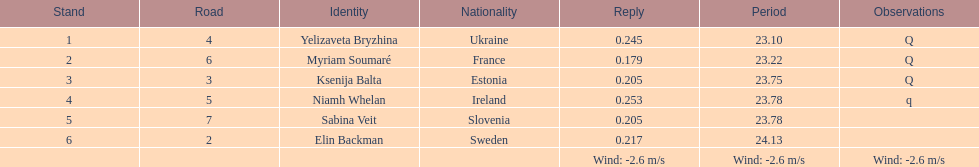Who is the first ranking player? Yelizaveta Bryzhina. 